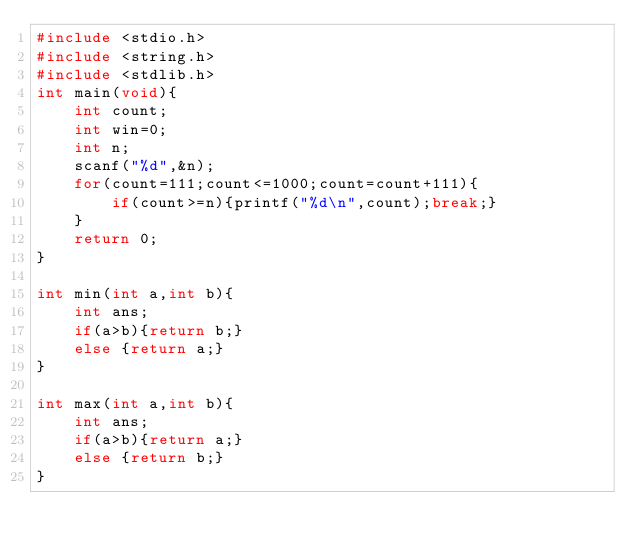<code> <loc_0><loc_0><loc_500><loc_500><_C_>#include <stdio.h>
#include <string.h>
#include <stdlib.h>
int main(void){
    int count;
    int win=0;
    int n;
    scanf("%d",&n);
    for(count=111;count<=1000;count=count+111){
        if(count>=n){printf("%d\n",count);break;}
    }
    return 0;
}

int min(int a,int b){
    int ans;
    if(a>b){return b;}
    else {return a;}
}

int max(int a,int b){
    int ans;
    if(a>b){return a;}
    else {return b;}
}</code> 